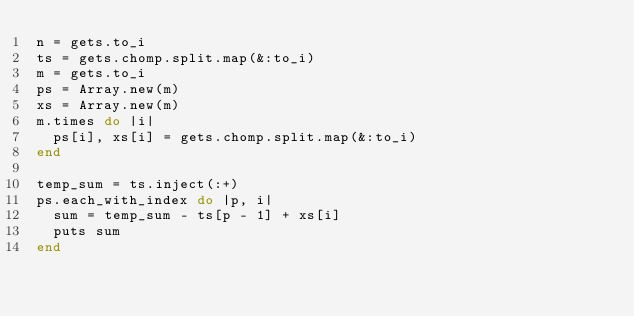<code> <loc_0><loc_0><loc_500><loc_500><_Ruby_>n = gets.to_i
ts = gets.chomp.split.map(&:to_i)
m = gets.to_i
ps = Array.new(m)
xs = Array.new(m)
m.times do |i|
  ps[i], xs[i] = gets.chomp.split.map(&:to_i)
end

temp_sum = ts.inject(:+)
ps.each_with_index do |p, i|
  sum = temp_sum - ts[p - 1] + xs[i]
  puts sum 
end</code> 